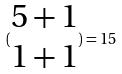Convert formula to latex. <formula><loc_0><loc_0><loc_500><loc_500>( \begin{matrix} 5 + 1 \\ 1 + 1 \end{matrix} ) = 1 5</formula> 